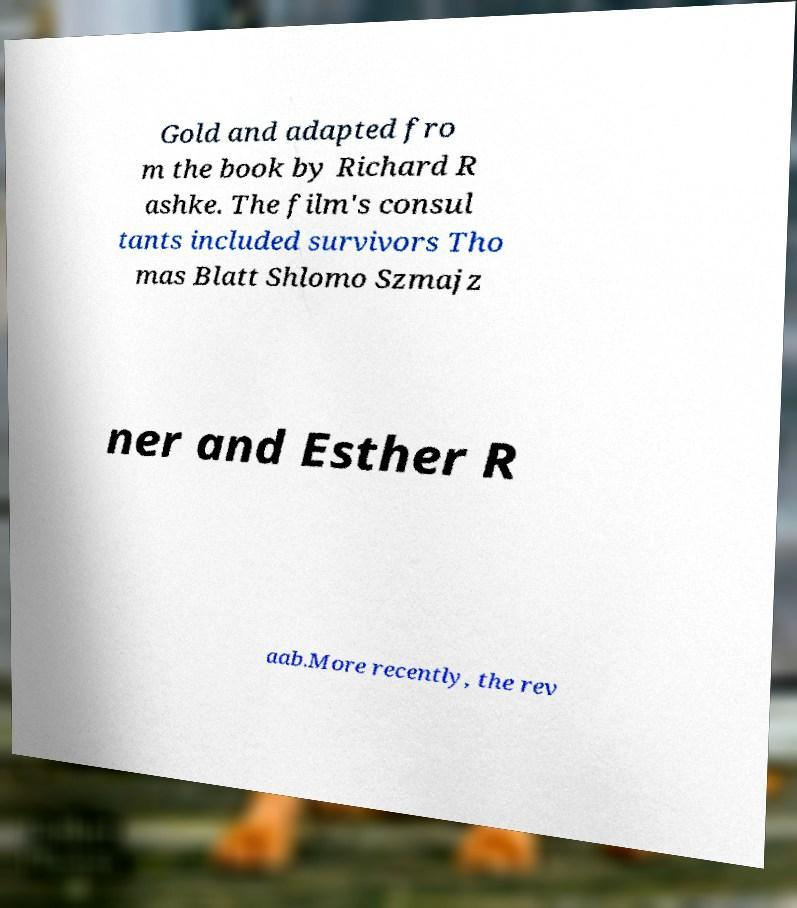Can you accurately transcribe the text from the provided image for me? Gold and adapted fro m the book by Richard R ashke. The film's consul tants included survivors Tho mas Blatt Shlomo Szmajz ner and Esther R aab.More recently, the rev 